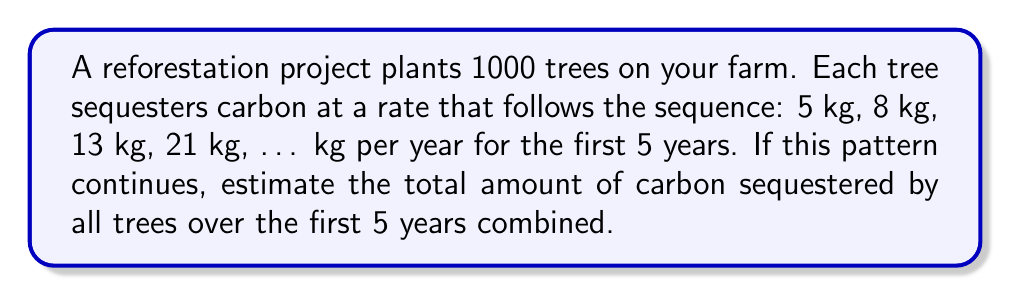Help me with this question. Let's approach this step-by-step:

1) First, we need to identify the pattern in the sequence:
   5, 8, 13, 21, ...
   This is a Fibonacci-like sequence where each term is the sum of the two preceding ones.

2) Let's complete the sequence for the 5th year:
   5, 8, 13, 21, 34

3) Now, we need to sum up these values to get the total carbon sequestered by one tree over 5 years:
   $S = 5 + 8 + 13 + 21 + 34 = 81$ kg

4) The question asks for the total amount sequestered by all 1000 trees. So we multiply our result by 1000:
   $T = 1000 \times S = 1000 \times 81 = 81,000$ kg

5) To convert kg to metric tons:
   $81,000 \text{ kg} = 81 \text{ metric tons}$

Therefore, over the first 5 years, all 1000 trees combined will sequester approximately 81 metric tons of carbon.
Answer: 81 metric tons 